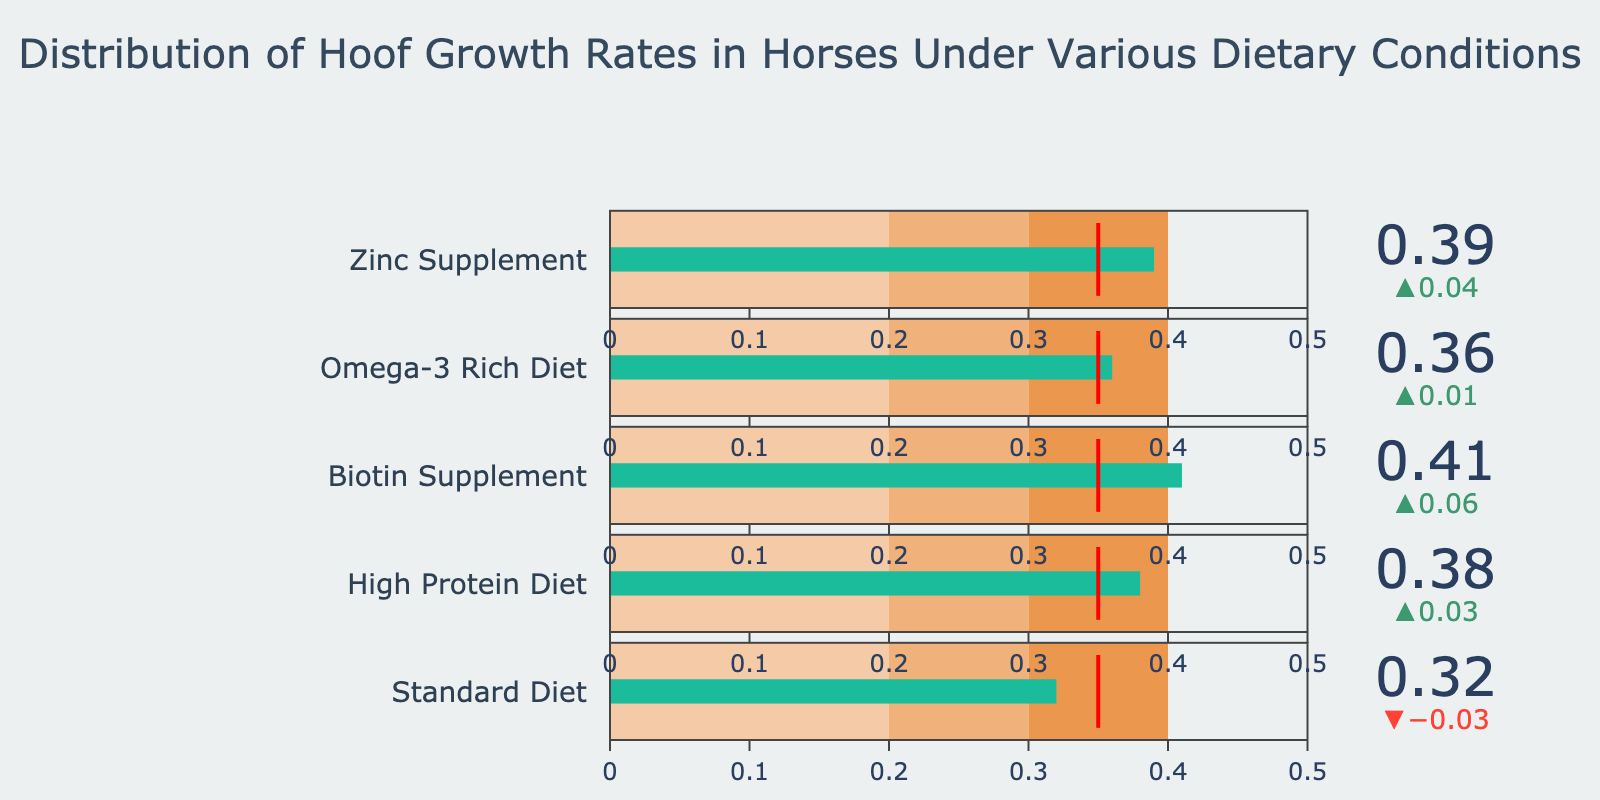what is the title of the plot? The title of the plot is usually displayed at the top center of the figure, often in a larger and bold font. Here, the title is "Distribution of Hoof Growth Rates in Horses Under Various Dietary Conditions"
Answer: Distribution of Hoof Growth Rates in Horses Under Various Dietary Conditions How many dietary conditions are compared in the figure? By counting the number of different titles on the bullet charts, we see there are 5 different dietary conditions. These are: Standard Diet, High Protein Diet, Biotin Supplement, Omega-3 Rich Diet, and Zinc Supplement
Answer: 5 Which dietary condition has the highest actual hoof growth rate? We need to look at the "Actual" values in each bullet chart. The highest actual value among the conditions is 0.41 under Biotin Supplement
Answer: Biotin Supplement Is the actual value for the Omega-3 Rich Diet above or below the comparative value? We compare the actual value of the Omega-3 Rich Diet (0.36) to its comparative value (0.35). 0.36 is higher than 0.35
Answer: Above What is the color of the bar representing the actual value in the bullet charts? In bullet charts, the bar representing the actual value is typically highlighted. In this case, the color used for these bars is a shade of green
Answer: Green What is the difference between the actual and comparative values for the Zinc Supplement? Find the actual value (0.39) and the comparative value (0.35). Subtract the comparative value from the actual value: 0.39 - 0.35 = 0.04
Answer: 0.04 Which dietary condition has the smallest difference between actual and comparative values? Calculate the difference for each condition and compare. The smallest difference is for the Omega-3 Rich Diet (0.36 - 0.35 = 0.01)
Answer: Omega-3 Rich Diet In which range does the actual value for the Biotin Supplement fall? Identify the ranges (0.2-0.3, 0.3-0.4, and above 0.4), then check the actual value for Biotin Supplement (0.41). 0.41 falls in the range above 0.4
Answer: Above 0.4 How many dietary conditions have actual values above the comparative value? Count the conditions where the actual value is higher than the comparative value. All 5 conditions (Standard Diet, High Protein Diet, Biotin Supplement, Omega-3 Rich Diet, Zinc Supplement) have actual values above the comparative value
Answer: 5 Which dietary condition's actual value is closest to the upper limit of the second range (0.3-0.4)? Identify the actual values closest to 0.4 without exceeding it. The closest actual value is 0.39 from Zinc Supplement
Answer: Zinc Supplement 